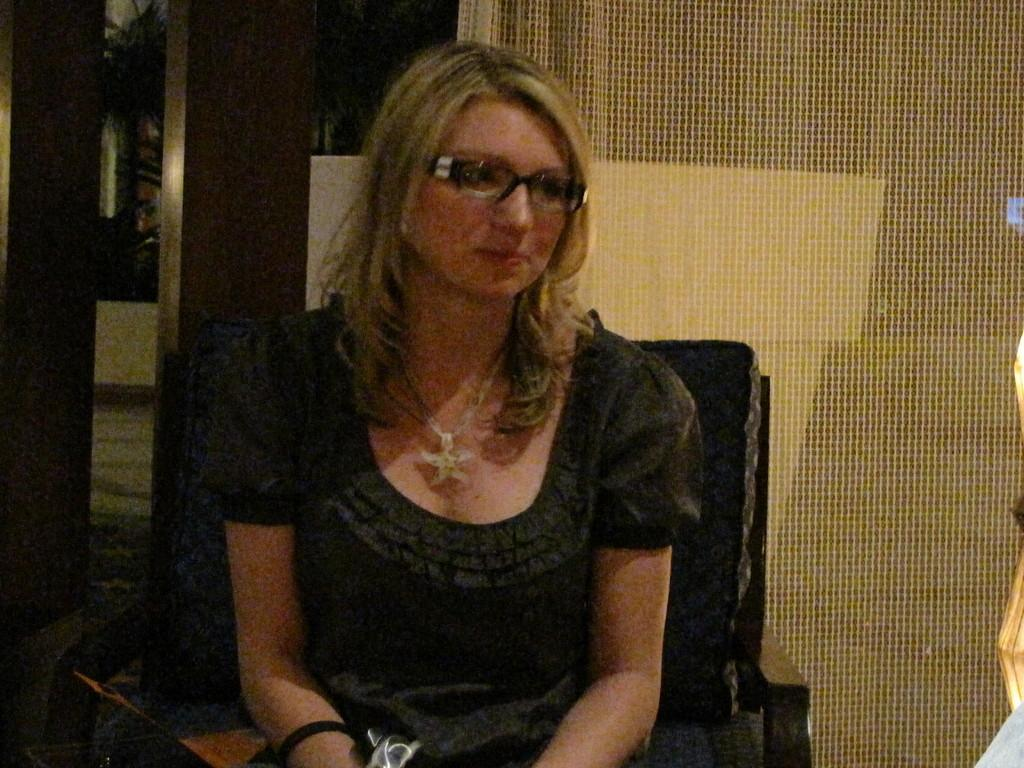Who is the main subject in the image? There is a woman in the image. What is the woman doing in the image? The woman is sitting on a chair. What can be seen in the background of the image? There is a curtain and a door in the background of the image. What is the woman's income in the image? There is no information about the woman's income in the image. How does the air affect the woman's hair in the image? There is no information about the air or the woman's hair in the image. 